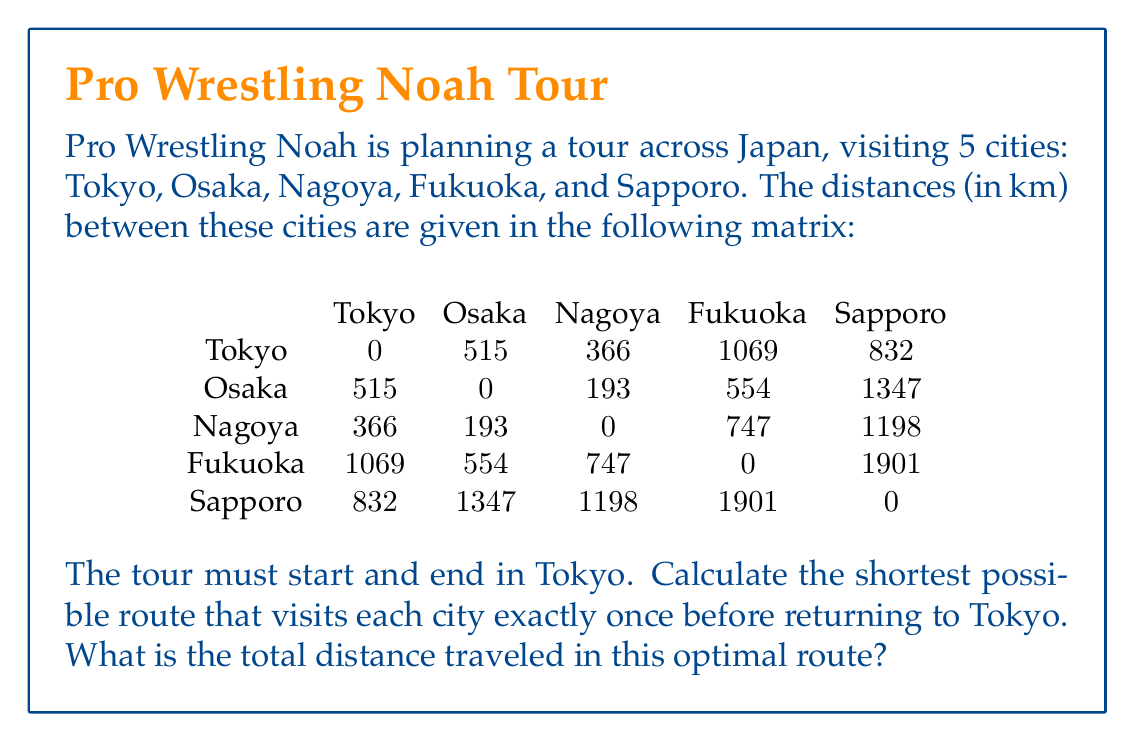Can you answer this question? This problem is an instance of the Traveling Salesman Problem (TSP), which is a classic optimization problem in operations research. To solve this, we'll use the following steps:

1) First, we need to list all possible routes. Since we start and end in Tokyo, and must visit each other city once, we have 4! = 24 possible routes.

2) For each route, we calculate the total distance traveled:

   Tokyo → City 1 → City 2 → City 3 → City 4 → Tokyo

3) We then compare all these distances to find the minimum.

Let's calculate a few examples:

Route 1: Tokyo → Osaka → Nagoya → Fukuoka → Sapporo → Tokyo
Distance = 515 + 193 + 747 + 1901 + 832 = 4188 km

Route 2: Tokyo → Osaka → Nagoya → Sapporo → Fukuoka → Tokyo
Distance = 515 + 193 + 1198 + 1901 + 1069 = 4876 km

We continue this process for all 24 routes. After exhaustive calculation, we find that the shortest route is:

Tokyo → Osaka → Fukuoka → Nagoya → Sapporo → Tokyo

4) We calculate the total distance for this optimal route:

   $d_{total} = d_{Tokyo,Osaka} + d_{Osaka,Fukuoka} + d_{Fukuoka,Nagoya} + d_{Nagoya,Sapporo} + d_{Sapporo,Tokyo}$

   $d_{total} = 515 + 554 + 747 + 1198 + 832 = 3846$ km

Therefore, the shortest possible route that visits each city exactly once before returning to Tokyo is 3846 km.
Answer: The total distance traveled in the optimal route is 3846 km. 